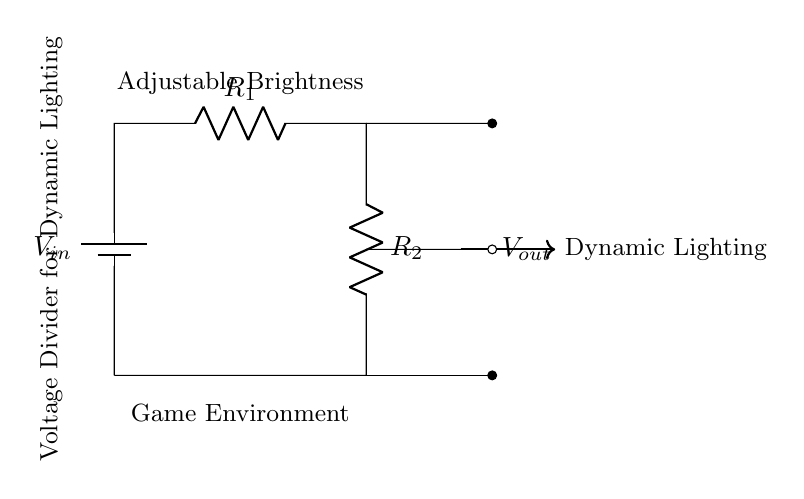What is the input voltage of the circuit? The input voltage is represented as V_in at the top left of the circuit diagram, indicating the starting voltage supplied to the voltage divider.
Answer: V_in What are the resistance values in the circuit? The circuit has two resistors labeled as R_1 and R_2. The diagram does not specify their numerical values, but they are distinct components in the voltage divider setup.
Answer: R_1, R_2 What is the purpose of the voltage divider in this diagram? The voltage divider is used to create a specific output voltage V_out, which is distinctly mentioned as being used for dynamic lighting effects in the game environment.
Answer: Dynamic Lighting How is V_out connected in the circuit? V_out is taken from the junction between R_1 and R_2. It’s indicated by a short line connecting to the output node, signifying that the voltage is measured across these two resistors.
Answer: From the junction of R_1 and R_2 What happens to the voltage across R_2 as R_1 increases while keeping R_2 constant? Increasing R_1 while keeping R_2 constant reduces the voltage drop across R_2 due to the voltage division rule, which dictates that V_out is a fraction of V_in based on the resistor values.
Answer: V_out decreases What role does the term "Adjustable Brightness" play in the circuit context? "Adjustable Brightness" signifies that by changing the resistance values (R_1 and R_2), the output voltage (and therefore the brightness of the lighting) can be manipulated, allowing for dynamic lighting effects in game environments.
Answer: Control of Brightness 